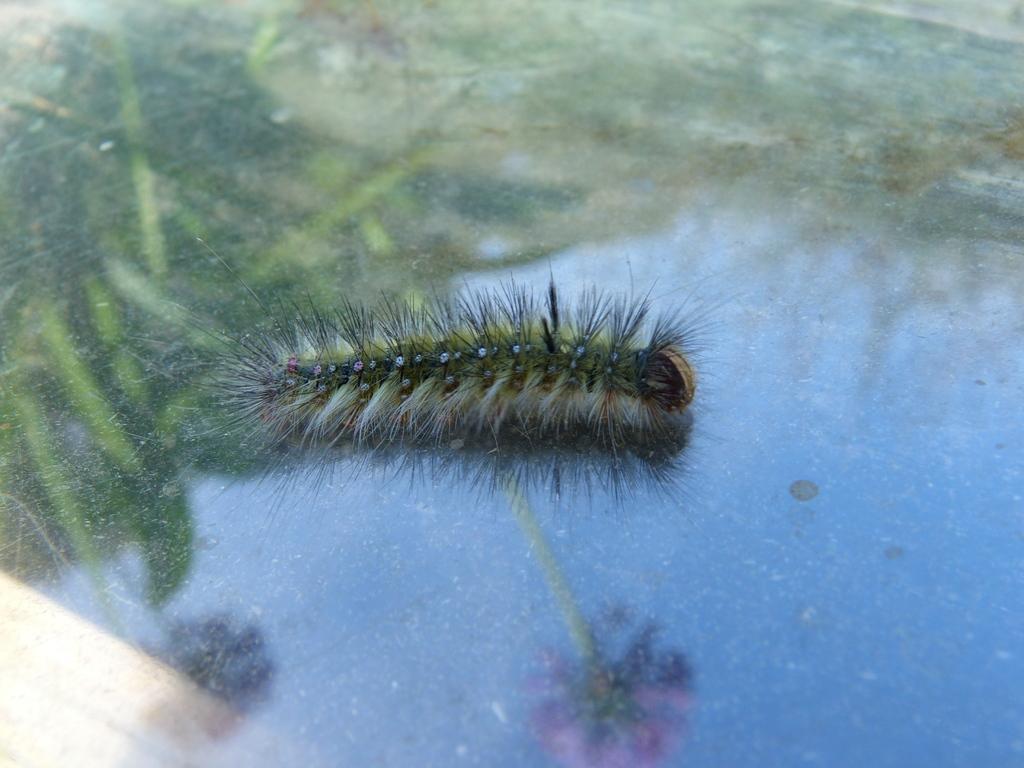Describe this image in one or two sentences. In this image we can see an insect on an object looks like a glass. On the object we can see the reflection of plants, flowers and the sky. 